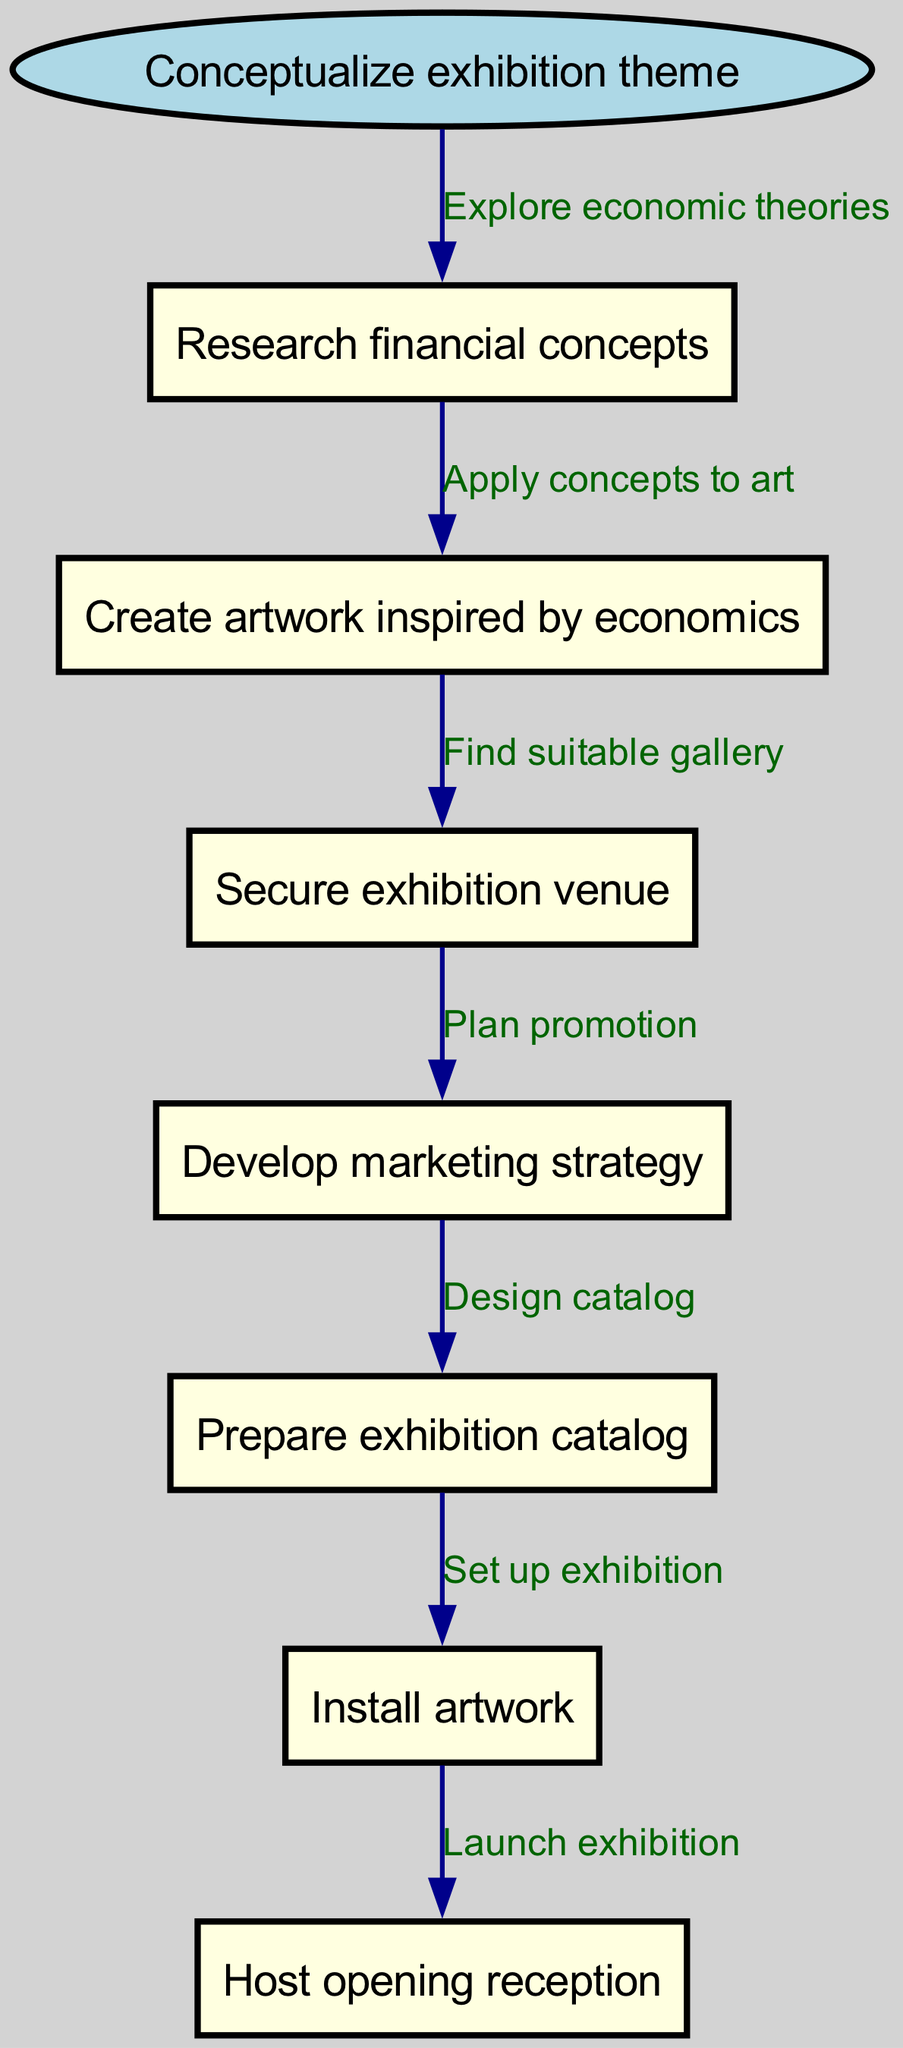What is the starting node of the flowchart? The starting node is labeled "Conceptualize exhibition theme," which is the first step in the flowchart.
Answer: Conceptualize exhibition theme How many nodes are in the diagram? There are a total of 8 nodes, including the starting node and all subsequent steps leading to the opening reception.
Answer: 8 Which node follows "Create artwork inspired by economics"? The diagram indicates that after creating the artwork, the next step is "Secure exhibition venue." This can be traced along the directed edges originating from the "Create artwork inspired by economics" node.
Answer: Secure exhibition venue What is the relationship between "Research financial concepts" and "Create artwork inspired by economics"? The edge connecting these two nodes is labeled "Apply concepts to art," indicating that the artwork creation process is based on the researched financial concepts.
Answer: Apply concepts to art What is the last step in the flowchart? The final step is labeled "Host opening reception," which completes the process indicated in the flowchart.
Answer: Host opening reception How many edges are there in the diagram? The diagram contains 7 edges, which connect all the nodes in the designated flow order from the start node to the end.
Answer: 7 What is the label on the edge connecting "Secure exhibition venue" and "Develop marketing strategy"? The edge between these nodes is labeled "Plan promotion," indicating the action taken after securing the venue.
Answer: Plan promotion What step involves designing the exhibition catalog? The step "Prepare exhibition catalog" represents the action of designing the catalog, following the marketing strategy development.
Answer: Prepare exhibition catalog 